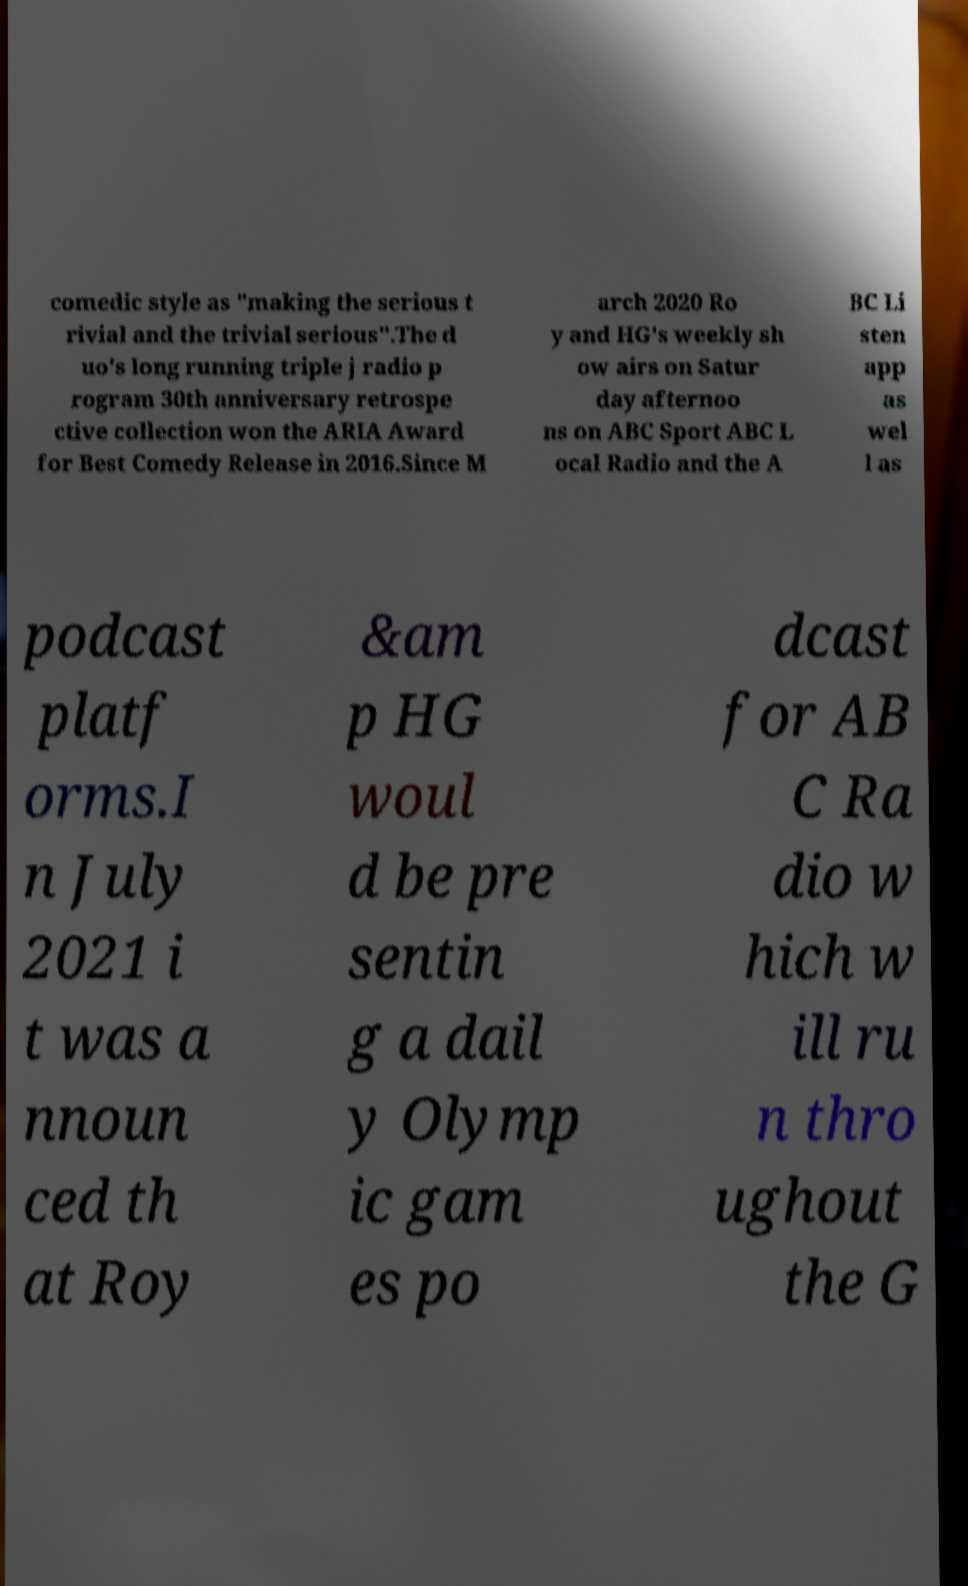Can you accurately transcribe the text from the provided image for me? comedic style as "making the serious t rivial and the trivial serious".The d uo's long running triple j radio p rogram 30th anniversary retrospe ctive collection won the ARIA Award for Best Comedy Release in 2016.Since M arch 2020 Ro y and HG's weekly sh ow airs on Satur day afternoo ns on ABC Sport ABC L ocal Radio and the A BC Li sten app as wel l as podcast platf orms.I n July 2021 i t was a nnoun ced th at Roy &am p HG woul d be pre sentin g a dail y Olymp ic gam es po dcast for AB C Ra dio w hich w ill ru n thro ughout the G 